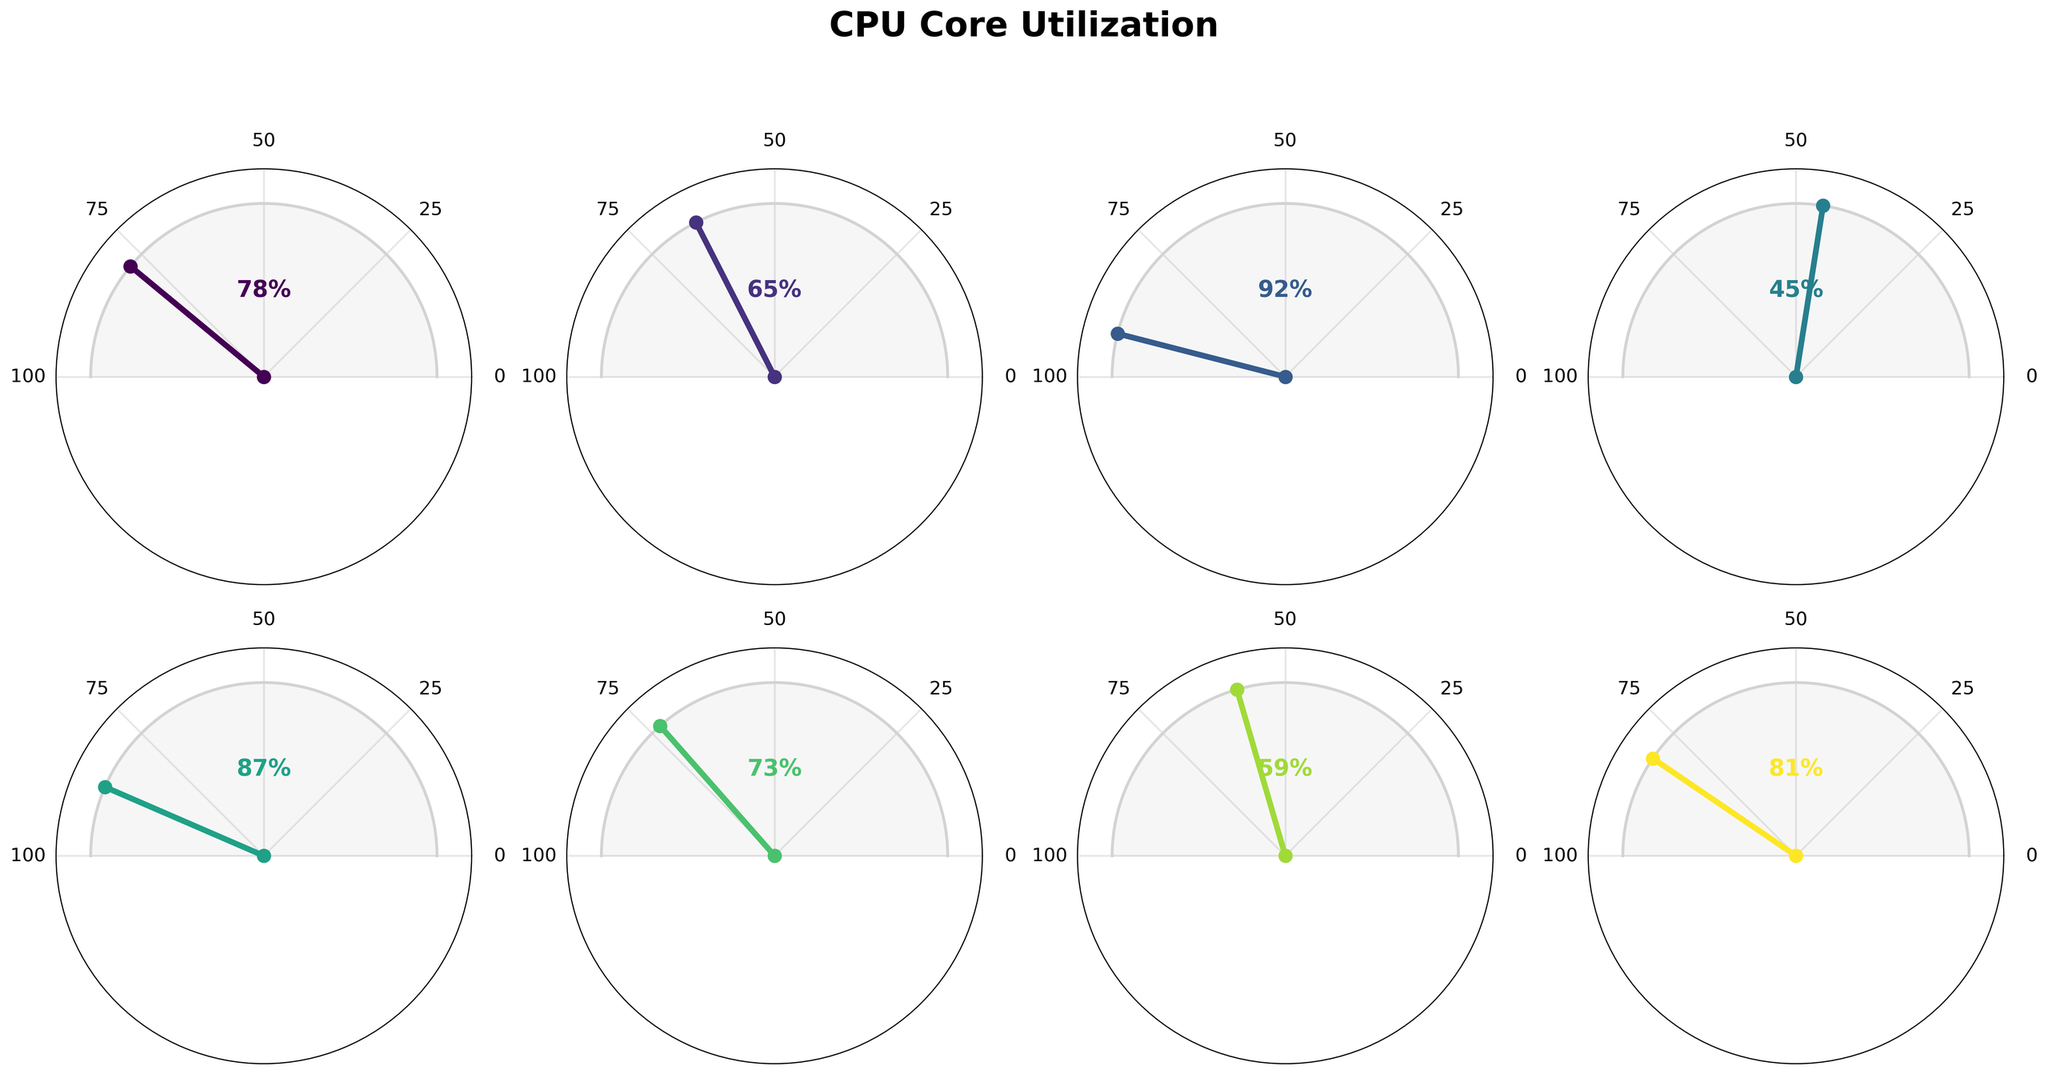What is the title of the figure? The title is located at the top of the figure and is usually given in a larger and bolder font. In this case, we can see the title "CPU Core Utilization" prominently displayed.
Answer: CPU Core Utilization How many CPU cores are displayed in the figure? Each gauge chart corresponds to one CPU core. By counting the number of individual gauges in the figure, we determine there are 8 CPU cores.
Answer: 8 Which core has the highest utilization? By inspecting each gauge and looking for the one with the needle pointing closest to 180 degrees, we identify that Core 3 has the highest utilization at 92%.
Answer: Core 3 What is the average utilization across all cores? To calculate the average, sum up the utilization percentages of all the cores (78 + 65 + 92 + 45 + 87 + 73 + 59 + 81) and divide by the total number of cores (8). The sum is 580, so the average is 580 / 8.
Answer: 72.5 What is the utilization difference between Core 1 and Core 4? Subtract the utilization of Core 4 from Core 1: 78% - 45%. This results in the difference of 33%.
Answer: 33% Which cores have a utilization greater than 80%? By comparing the utilization values shown in each gauge, we see that Core 3, Core 5, and Core 8 all have utilization percentages greater than 80%.
Answer: Core 3, Core 5, Core 8 What's the median utilization value among the CPU cores? To find the median, list the utilization values in ascending order: 45, 59, 65, 73, 78, 81, 87, 92. The median is the average of the two middle values (73 and 78). Median = (73 + 78) / 2 = 75.5.
Answer: 75.5 Which core has the lowest utilization? By inspecting each gauge and locating the needle pointing closest to 0 degrees, we identify that Core 4 has the lowest utilization at 45%.
Answer: Core 4 How many cores have a utilization between 60% and 80%? We count the cores whose utilization falls within the range of 60% to 80%. By checking each gauge, we find that Core 1 (78%), Core 2 (65%), Core 6 (73%), and Core 7 (59%) fit this criterion, although Core 7 slightly falls short. So we count three cores.
Answer: 3 